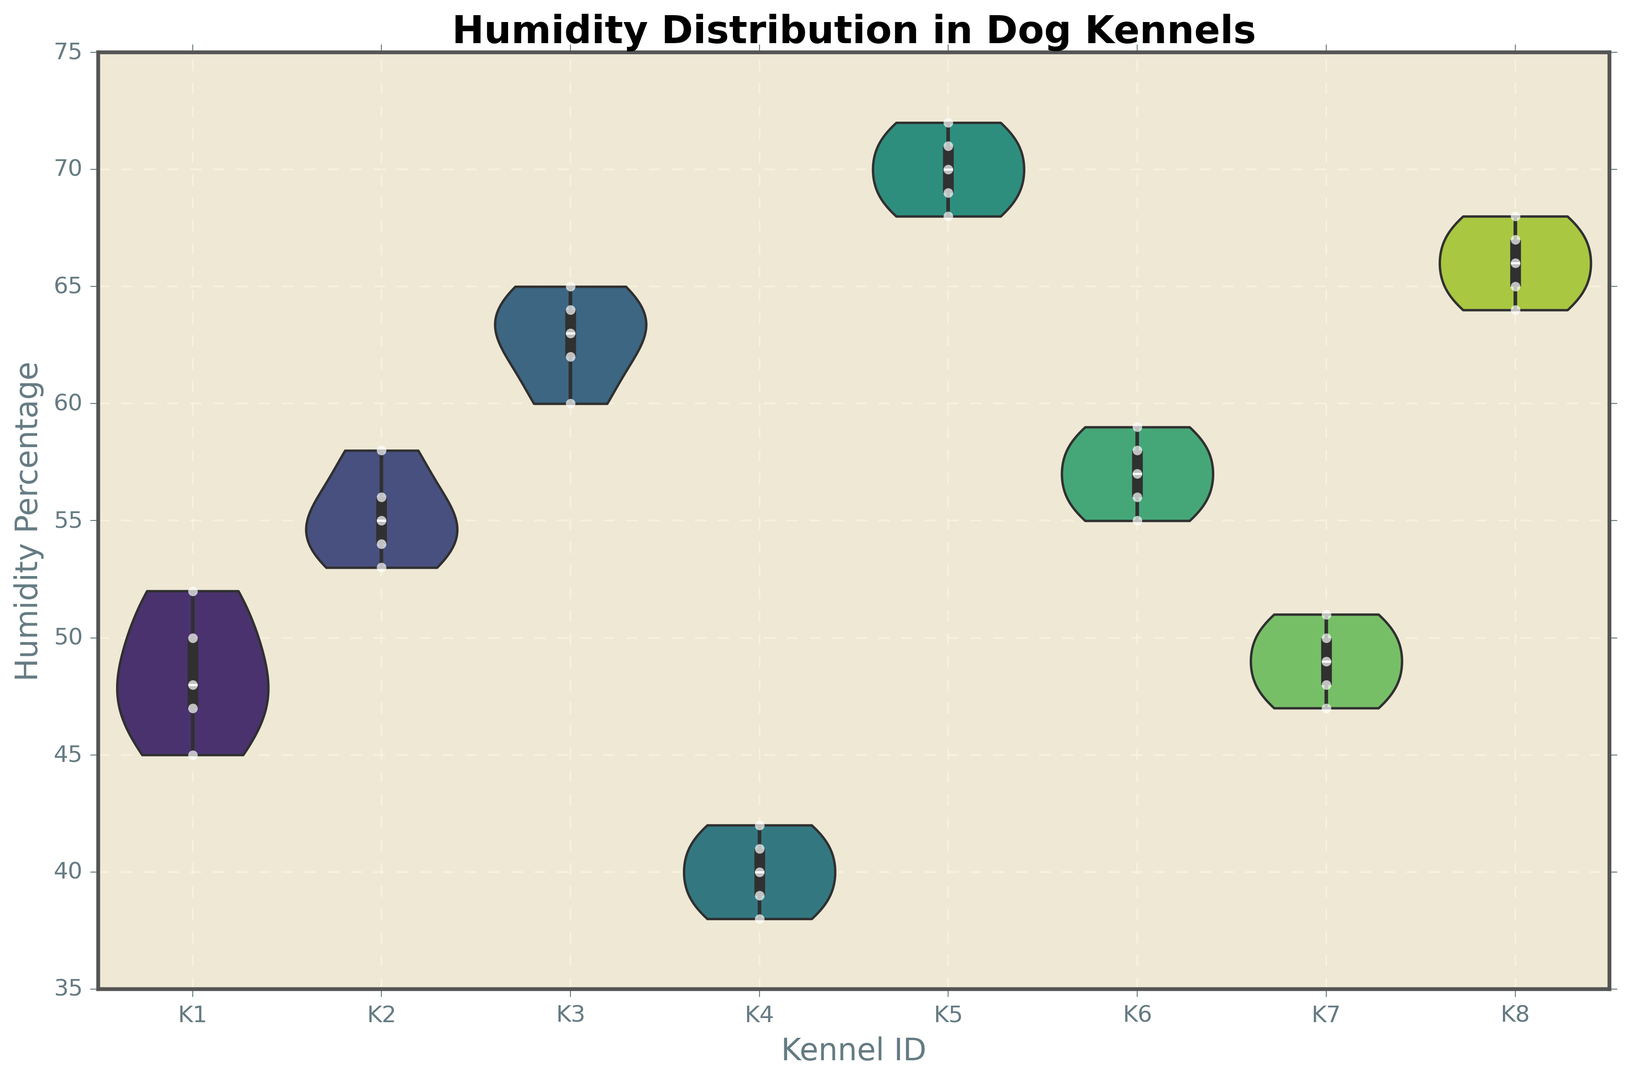Which kennel has the highest median humidity percentage? By observing the centerline within the violin plots, which represents the median, the plot for Kennel K5 displays the highest median humidity percentage compared to the others.
Answer: Kennel K5 Which kennel has the lowest range of humidity percentage? By comparing the span of each violin plot, Kennel K4 has the smallest vertical range, indicating the tightest range of humidity percentages.
Answer: Kennel K4 Between Kennel K1 and Kennel K2, which one has a higher maximum humidity percentage? The top edges of the violin plots for Kennel K1 and Kennel K2 can be compared visually. Kennel K2 has a higher top edge, indicating a higher maximum humidity percentage.
Answer: Kennel K2 What is the general shape of the humidity distribution in Kennel K3? The shape of the violin plot for Kennel K3 shows that it is relatively symmetrical with a slight bulge in the middle, indicating a normal-like distribution.
Answer: Symmetrical Is there any kennel where the humidity percentage does not exceed 50%? By observing the top edges of the violin plots, Kennel K4 has the highest edge below the 50% humidity mark.
Answer: Kennel K4 Which kennels exhibit multimodal distributions, if any? If there are any violin plots with multiple peaks or bulges, these indicate multimodal distributions. The plots for the kennels reviewed do not show distinct multiple peaks.
Answer: None What is the median humidity percentage for Kennel K6? The horizontal line within the violin plot for Kennel K6 represents the median, which appears to be around the 57% mark.
Answer: 57% How do the distributions of humidity in Kennel K7 and Kennel K8 compare? By comparing the shapes, sizes, and spans of the violin plots for Kennel K7 and Kennel K8, Kennel K8 has a wider range and slightly higher median than Kennel K7.
Answer: Kennel K8 has higher range and median Which kennel appears to have the most evenly distributed humidity percentages? A smooth, uniformly shaped violin plot indicates even distribution. Kennel K8 shows a broadly consistent distribution, suggesting evenly spread humidity percentages.
Answer: Kennel K8 What is the approximate interquartile range of humidity percentages in Kennel K5? The interquartile range can be estimated by observing the middle 50% spread of the data within the violin plot. For Kennel K5, it spans from around 68% to 71%.
Answer: 3% 